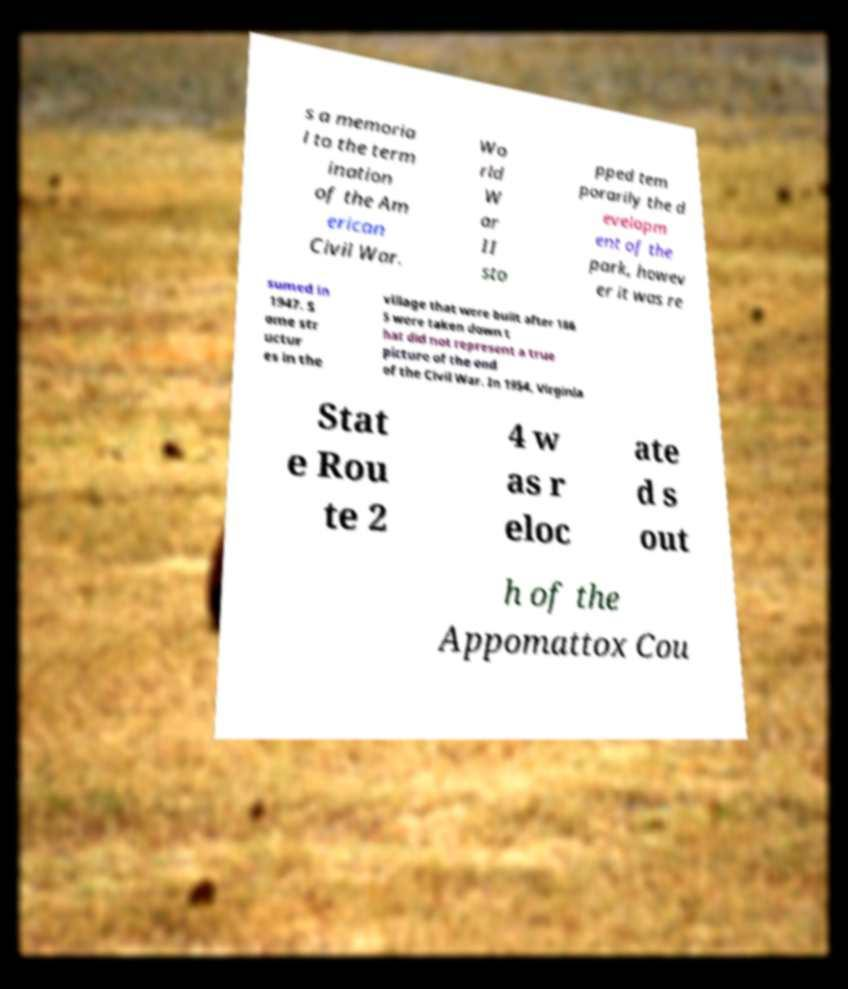I need the written content from this picture converted into text. Can you do that? s a memoria l to the term ination of the Am erican Civil War. Wo rld W ar II sto pped tem porarily the d evelopm ent of the park, howev er it was re sumed in 1947. S ome str uctur es in the village that were built after 186 5 were taken down t hat did not represent a true picture of the end of the Civil War. In 1954, Virginia Stat e Rou te 2 4 w as r eloc ate d s out h of the Appomattox Cou 